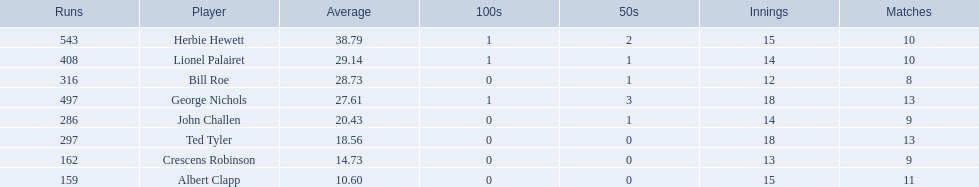Who are the players in somerset county cricket club in 1890? Herbie Hewett, Lionel Palairet, Bill Roe, George Nichols, John Challen, Ted Tyler, Crescens Robinson, Albert Clapp. Who is the only player to play less than 13 innings? Bill Roe. 